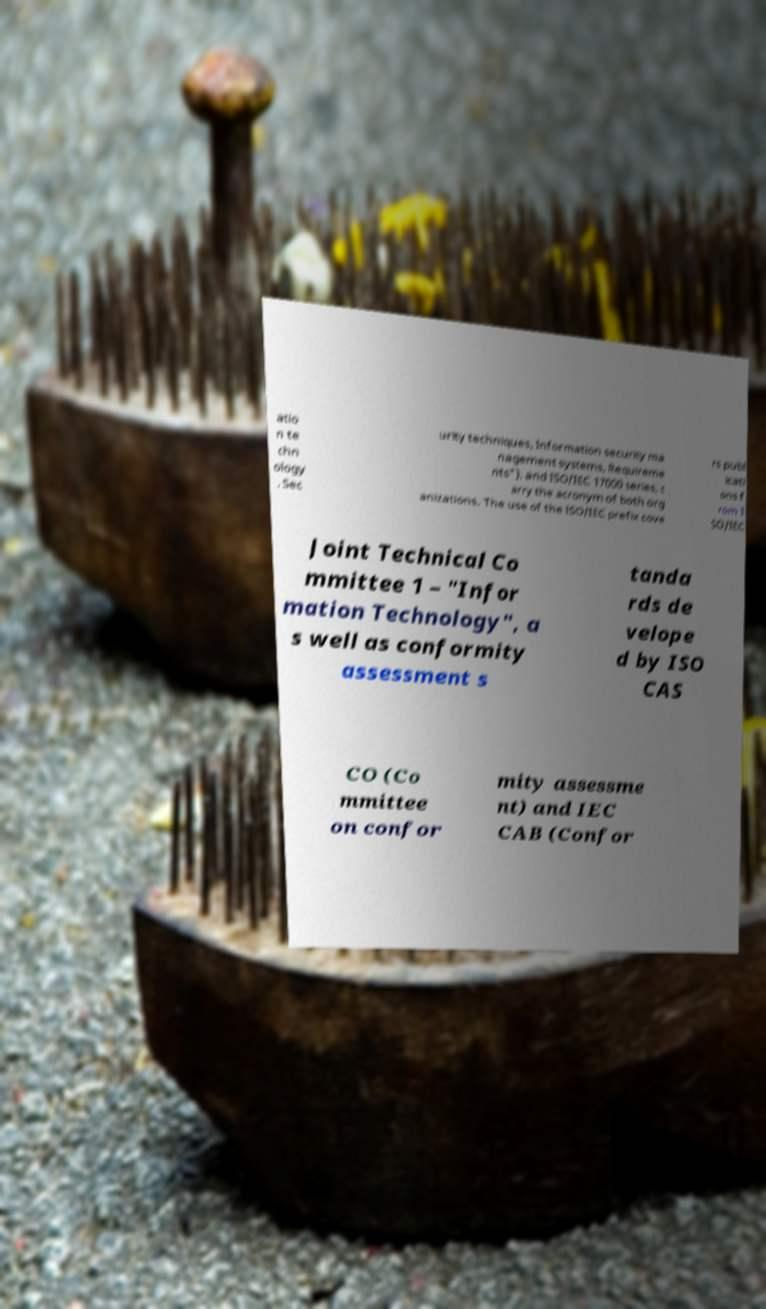Could you extract and type out the text from this image? atio n te chn ology , Sec urity techniques, Information security ma nagement systems, Requireme nts"), and ISO/IEC 17000 series, c arry the acronym of both org anizations. The use of the ISO/IEC prefix cove rs publ icati ons f rom I SO/IEC Joint Technical Co mmittee 1 – "Infor mation Technology", a s well as conformity assessment s tanda rds de velope d by ISO CAS CO (Co mmittee on confor mity assessme nt) and IEC CAB (Confor 